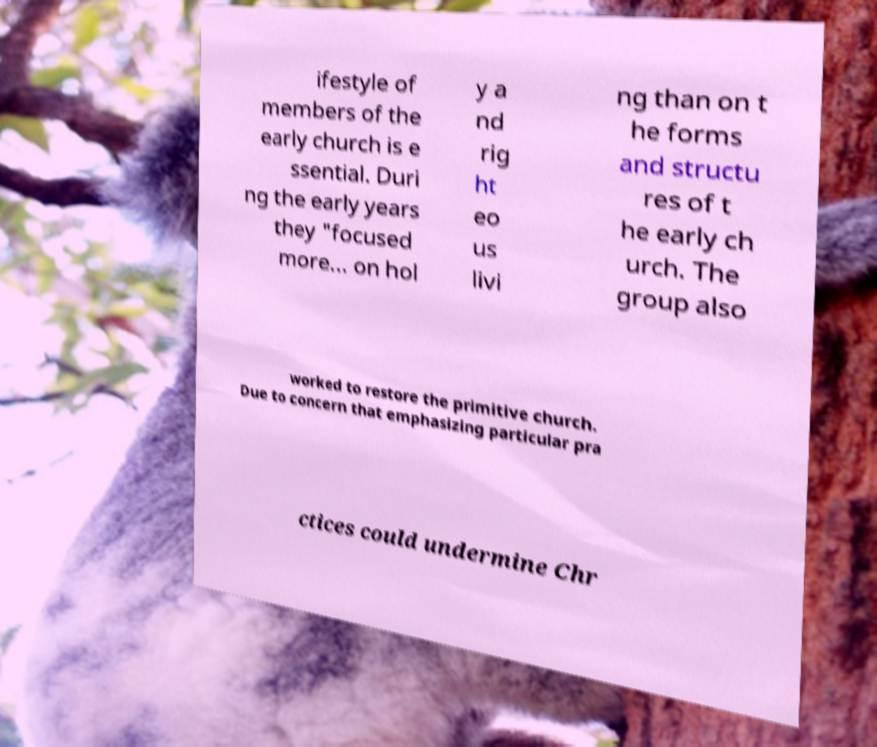Please read and relay the text visible in this image. What does it say? ifestyle of members of the early church is e ssential. Duri ng the early years they "focused more... on hol y a nd rig ht eo us livi ng than on t he forms and structu res of t he early ch urch. The group also worked to restore the primitive church. Due to concern that emphasizing particular pra ctices could undermine Chr 